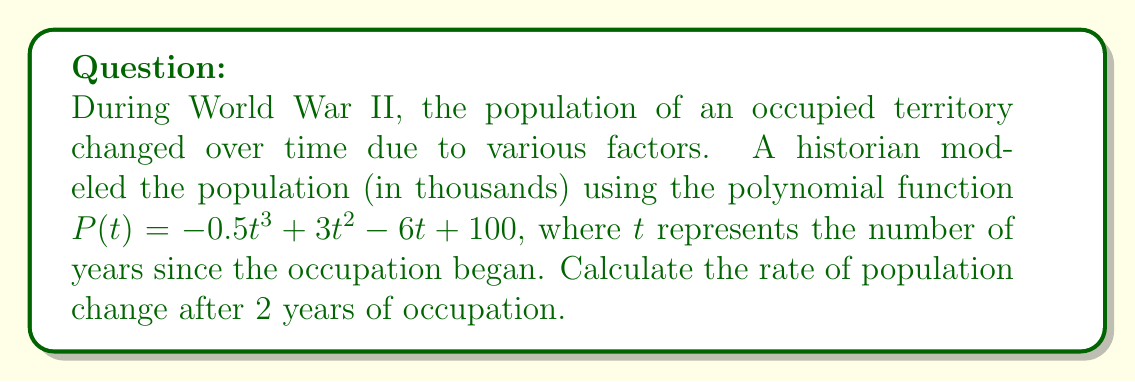Can you solve this math problem? To find the rate of population change, we need to calculate the derivative of the population function $P(t)$ and evaluate it at $t = 2$.

1. Given population function: $P(t) = -0.5t^3 + 3t^2 - 6t + 100$

2. Calculate the derivative $P'(t)$:
   $P'(t) = \frac{d}{dt}(-0.5t^3 + 3t^2 - 6t + 100)$
   $P'(t) = -1.5t^2 + 6t - 6$

3. Evaluate $P'(t)$ at $t = 2$:
   $P'(2) = -1.5(2)^2 + 6(2) - 6$
   $P'(2) = -1.5(4) + 12 - 6$
   $P'(2) = -6 + 12 - 6$
   $P'(2) = 0$

The rate of population change after 2 years of occupation is 0 thousand people per year.

This result suggests that the population reached a turning point at $t = 2$, transitioning from growth to decline or vice versa. This could represent a significant moment in the territory's history, such as a change in occupation policies or a major event affecting the population.
Answer: 0 thousand people per year 